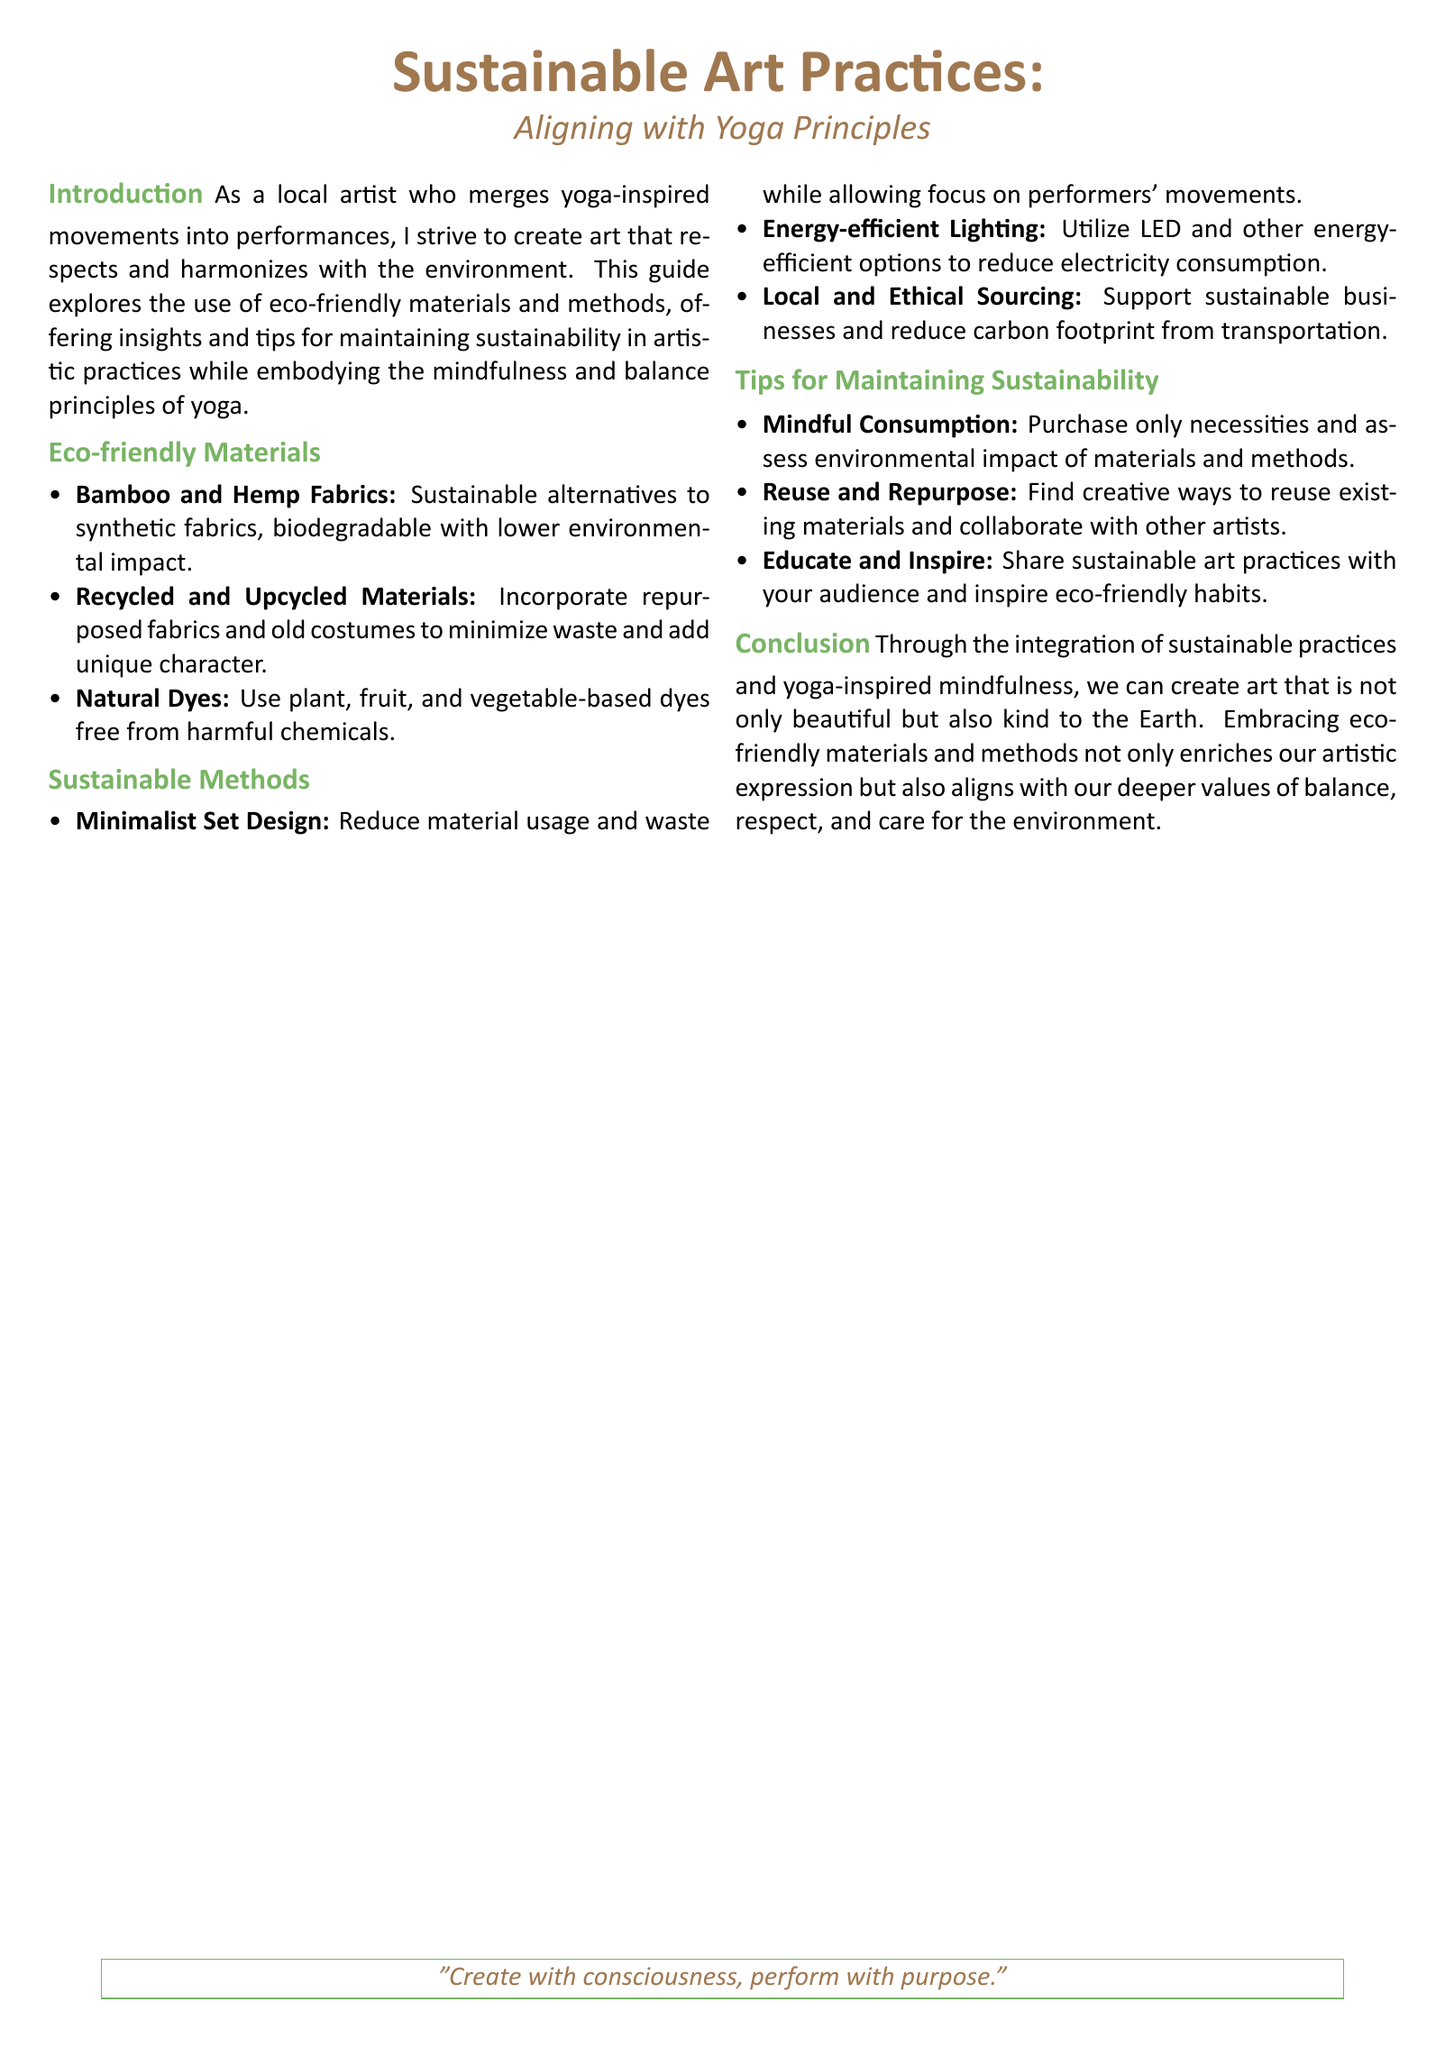What are two eco-friendly fabrics mentioned? The document lists bamboo and hemp fabrics as sustainable alternatives.
Answer: Bamboo and hemp What method reduces material usage in set design? The document emphasizes minimalist set design as a method to decrease material usage.
Answer: Minimalist set design What type of lighting is recommended for sustainability? The document suggests using energy-efficient lighting options to minimize electricity consumption.
Answer: Energy-efficient lighting How can artists influence their audience regarding sustainability? The document recommends that artists share sustainable practices to inspire eco-friendly habits in their audience.
Answer: Educate and inspire What is the overall theme of the document? The document discusses aligning sustainable art practices with yoga principles.
Answer: Sustainable art practices Which natural dyes are encouraged in the document? The document states that plant, fruit, and vegetable-based dyes are preferred over harmful chemicals.
Answer: Plant, fruit, and vegetable-based dyes 